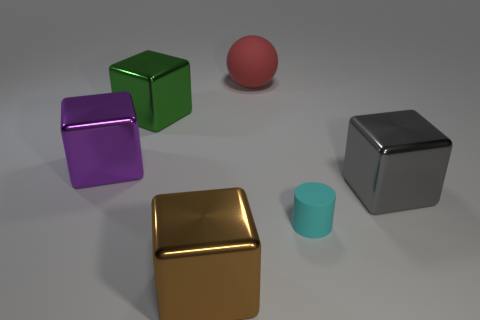What does the presence of multiple colors say about the objects? The variety of colors can indicate differing materials or simply an artist's choice to represent diversity. It enhances the visual appeal of the scene and allows each object to stand out, making it easier to distinguish their individual shapes. 